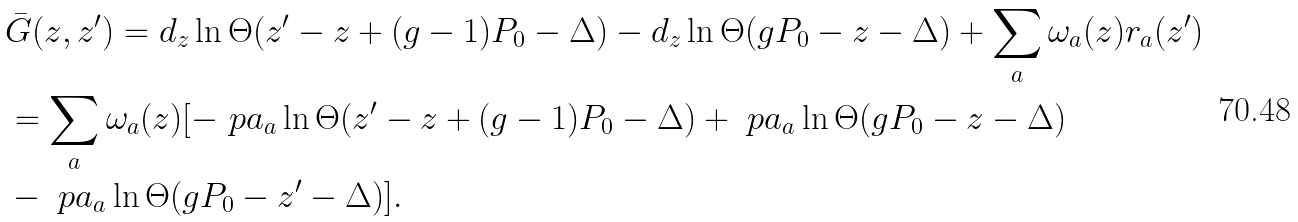<formula> <loc_0><loc_0><loc_500><loc_500>& \bar { G } ( z , z ^ { \prime } ) = d _ { z } \ln \Theta ( z ^ { \prime } - z + ( g - 1 ) P _ { 0 } - \Delta ) - d _ { z } \ln \Theta ( g P _ { 0 } - z - \Delta ) + \sum _ { a } \omega _ { a } ( z ) r _ { a } ( z ^ { \prime } ) \\ & = \sum _ { a } \omega _ { a } ( z ) [ - \ p a _ { a } \ln \Theta ( z ^ { \prime } - z + ( g - 1 ) P _ { 0 } - \Delta ) + \ p a _ { a } \ln \Theta ( g P _ { 0 } - z - \Delta ) \\ & - \ p a _ { a } \ln \Theta ( g P _ { 0 } - z ^ { \prime } - \Delta ) ] .</formula> 